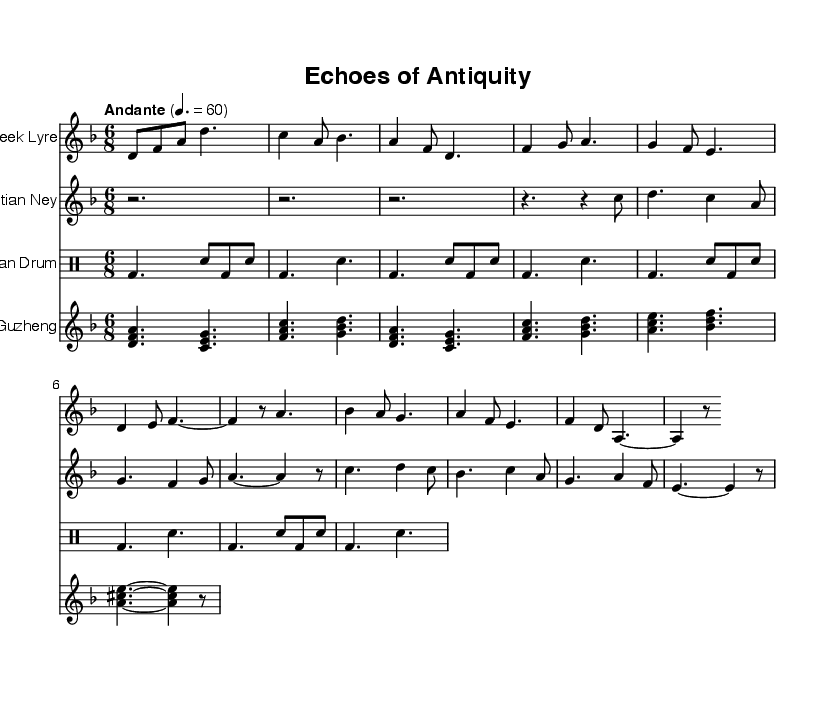What is the key signature of this music? The key signature is D minor, which typically includes one flat (B flat). You can identify this by looking at the beginning of the score where the key signature is notated.
Answer: D minor What is the time signature of this piece? The time signature indicated in the score is 6/8, which means there are six eighth notes per measure. This is visible in the initial section of the score where the time signature is marked.
Answer: 6/8 What is the tempo marking given in this sheet music? The tempo marking in the score reads "Andante" with a metronome marking of 60 beats per minute. This is stated at the beginning of the score, directly under the global section.
Answer: Andante Which instruments are featured in this composition? The composition features four instruments: the Ancient Greek Lyre, the Egyptian Ney, the Mayan Drum, and the Chinese Guzheng. Each instrument is indicated at the start of its respective staff.
Answer: Ancient Greek Lyre, Egyptian Ney, Mayan Drum, Chinese Guzheng How many measures does the Ancient Greek Lyre part contain? The Ancient Greek Lyre part consists of 8 measures. You can count the measures in the staff specifically designated for the Lyre part; each measure is separated by vertical bars.
Answer: 8 What rhythmic pattern is dominant in the Mayan Drum part? The Mayan Drum part primarily employs a pattern that alternates between bass drum and snare hits, shown by their respective notations. This consistent alternation creates a clear rhythmic foundation characterized by the use of quarter notes and eighth notes.
Answer: Bass and snare alternating What type of scales do the melodies in this fusion seem to incorporate? The melodies from the instruments appear to incorporate modal scales, suggested by the diverse pitches that reflect characteristics of ancient music traditions. The use of specific notes like B flat in the D minor scale provides a hint as to _particular modes_ being utilized.
Answer: Modal scales 